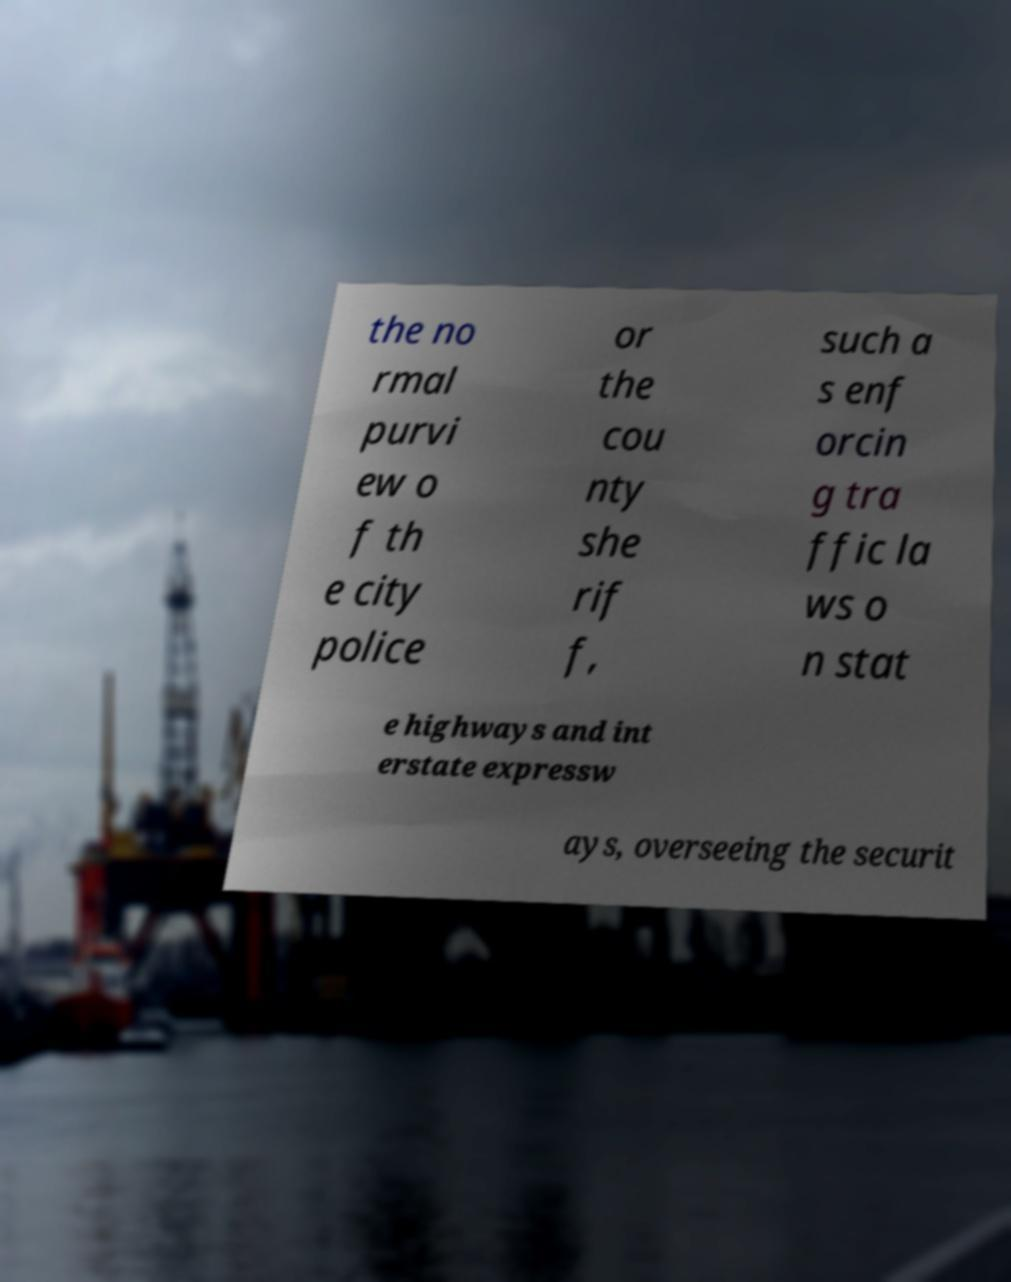Can you accurately transcribe the text from the provided image for me? the no rmal purvi ew o f th e city police or the cou nty she rif f, such a s enf orcin g tra ffic la ws o n stat e highways and int erstate expressw ays, overseeing the securit 